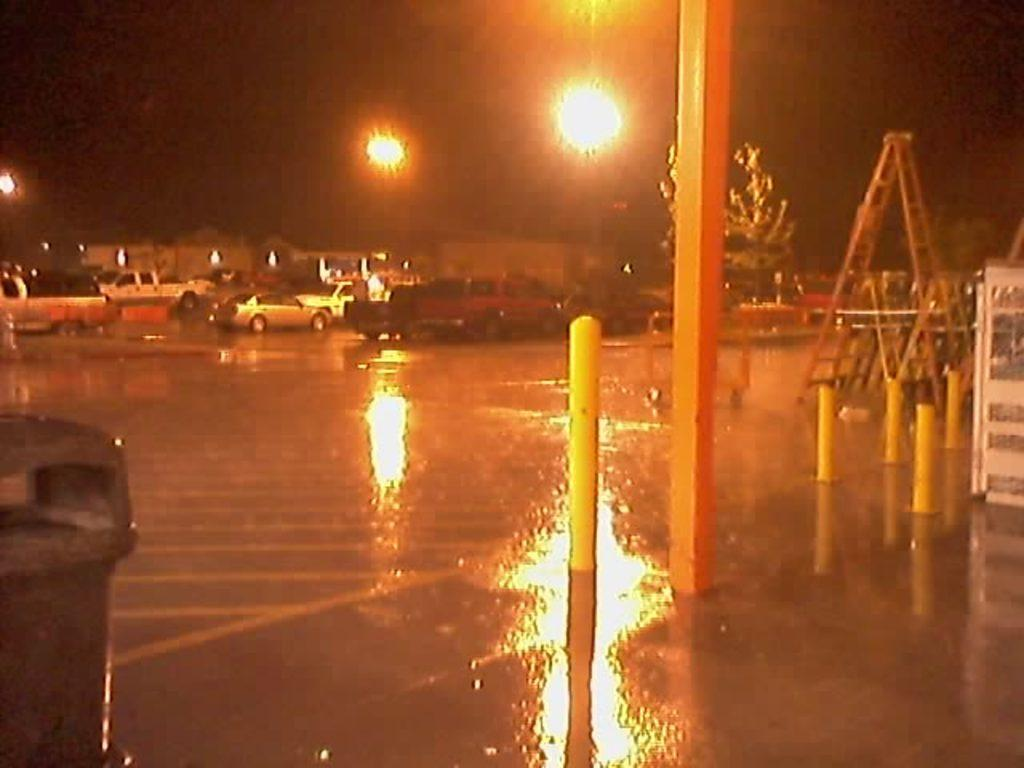What type of structures are present in the image? There are pillars in the image. What type of vehicles can be seen in the image? There are cars in the image. What type of illumination is present in the image? There are lights in the image. Where is the dustbin located in the image? The dustbin is on the left side of the image. What type of vegetation is visible behind a pillar in the image? There is a tree behind a pillar in the image. How many chickens are attending the party in the image? There are no chickens or party present in the image. What type of muscle is visible on the pillars in the image? There is no muscle visible on the pillars in the image; they are inanimate structures. 